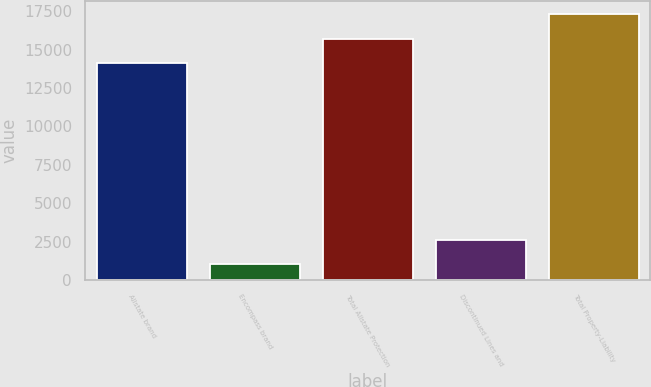Convert chart. <chart><loc_0><loc_0><loc_500><loc_500><bar_chart><fcel>Allstate brand<fcel>Encompass brand<fcel>Total Allstate Protection<fcel>Discontinued Lines and<fcel>Total Property-Liability<nl><fcel>14123<fcel>1027<fcel>15723.1<fcel>2627.1<fcel>17323.2<nl></chart> 